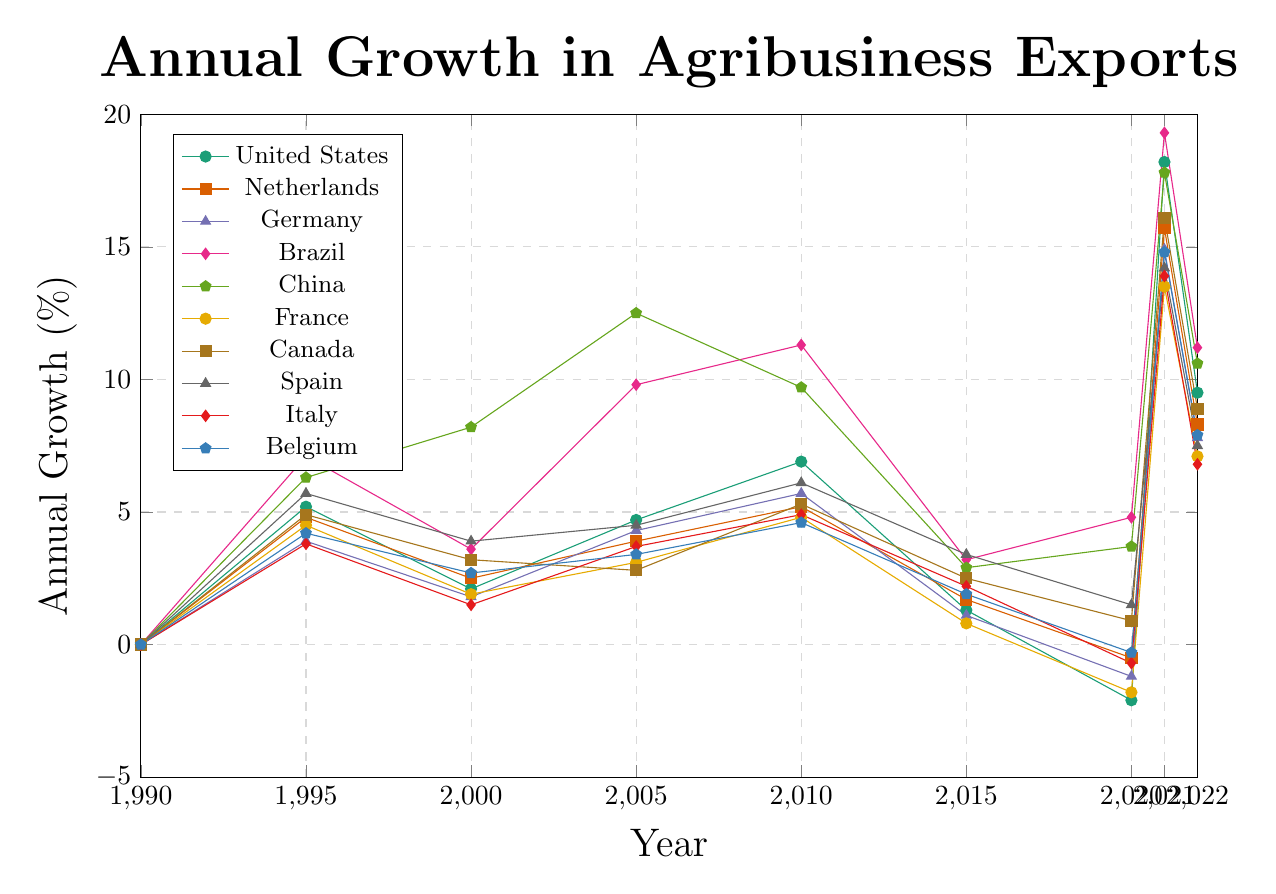Which country had the highest increase in growth between 2020 and 2021? To determine the highest increase, look at the growth values for each country between 2020 and 2021 and calculate the differences. Brazil had an increase from 4.8% to 19.3%, which is the highest increase (14.5%).
Answer: Brazil How did the United States' growth in 2022 compare to its growth in 2015? Check the growth values for the United States in 2022 and 2015. The values are 9.5% in 2022 and 1.3% in 2015. Comparing these, the growth in 2022 is significantly higher.
Answer: Higher Which country had the lowest growth rate in 2015? Compare the growth rates of all countries in 2015. France had the lowest growth rate at 0.8%.
Answer: France What was the approximate average growth rate for Brazil from 1990 to 2022? Sum the growth rates for Brazil across the given years and divide by the number of years. The growth rates are (0 + 7.1 + 3.6 + 9.8 + 11.3 + 3.2 + 4.8 + 19.3 + 11.2)/9, which is approximately 7.8%.
Answer: 7.8% Which country had a negative growth rate in 2020 and a significantly positive growth rate in 2021? Identify countries that had negative growth rates in 2020 and then check their growth rates in 2021. United States had -2.1% in 2020 and 18.2% in 2021.
Answer: United States Between 2005 and 2010, which country showed the highest increase in growth rate? Calculate the growth rate differences for each country between 2005 and 2010. China had the highest increase, from 12.5% to 9.7% even though it was a decrease not considering countries with actual increases. The actual increase was from Canada from 2.8% to 5.3% or 2.5%.
Answer: Canada Which countries had a growth rate higher than 10% in 2021? Check the growth rates for each country in 2021 and list those above 10%. The countries are United States, Netherlands, Germany, Brazil, China, Canada, Spain, Italy, and Belgium.
Answer: All except France Who had the least variance in growth from 1990 to 2022? Calculate the difference between the highest and lowest growth rates for each country. France had the least variance in growth with the range between -1.8% to 13.5%.
Answer: France 